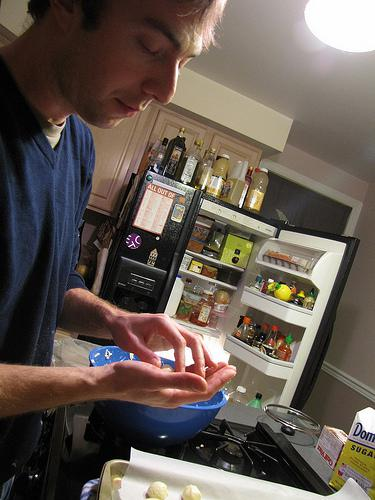Question: what is the person doing?
Choices:
A. Singing.
B. Cooking.
C. Talking on the telephone.
D. Walking in a marathon.
Answer with the letter. Answer: B Question: what room is the person in?
Choices:
A. Bathroom.
B. The livingroom.
C. Kitchen.
D. The diningroom.
Answer with the letter. Answer: C Question: what color is the person's shirt?
Choices:
A. Red.
B. Blue.
C. White.
D. Gray.
Answer with the letter. Answer: B Question: how many people are there?
Choices:
A. Two.
B. One.
C. Three.
D. Four.
Answer with the letter. Answer: B 